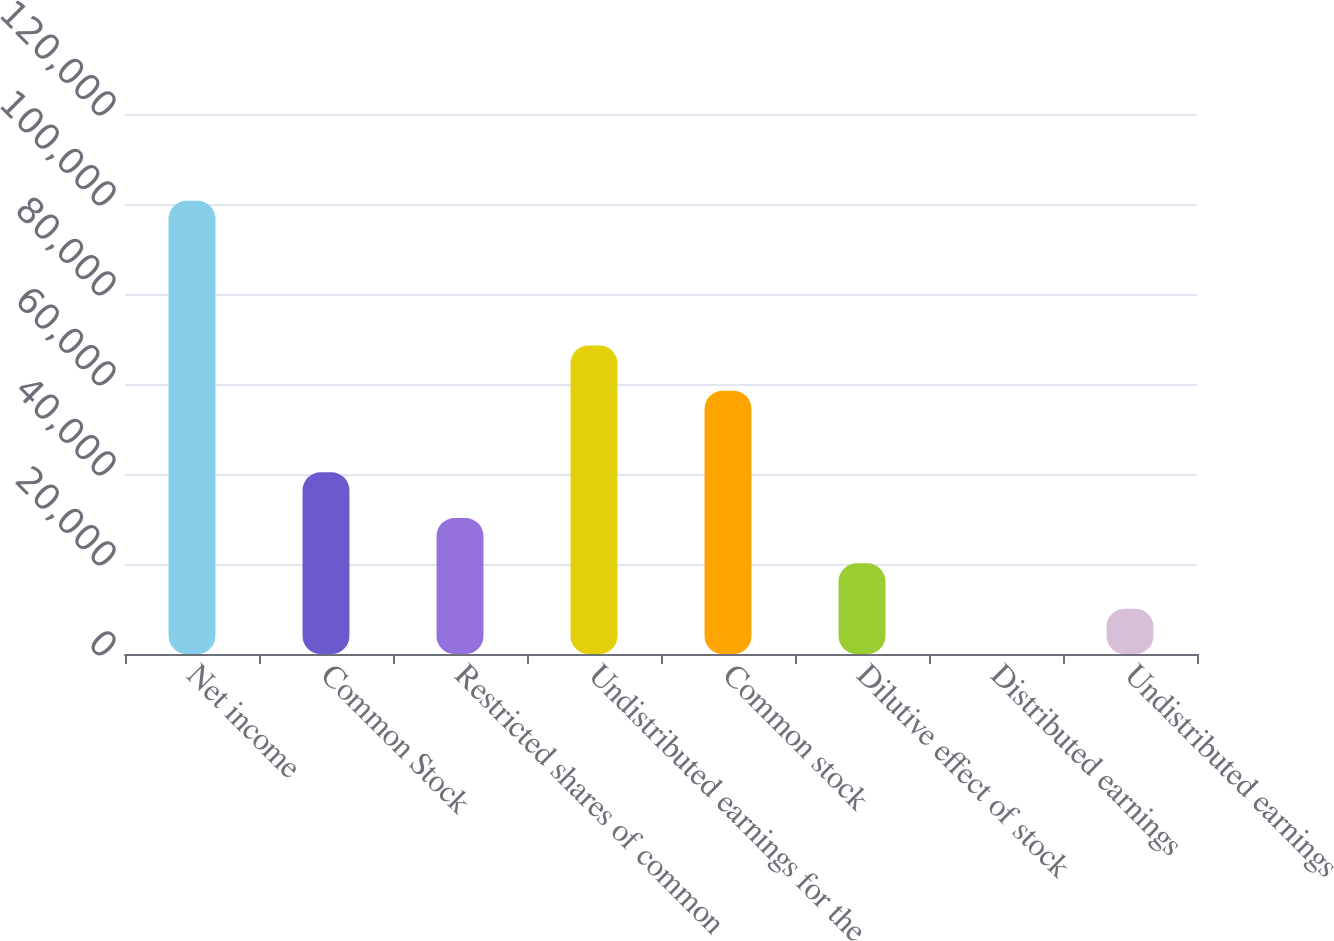Convert chart to OTSL. <chart><loc_0><loc_0><loc_500><loc_500><bar_chart><fcel>Net income<fcel>Common Stock<fcel>Restricted shares of common<fcel>Undistributed earnings for the<fcel>Common stock<fcel>Dilutive effect of stock<fcel>Distributed earnings<fcel>Undistributed earnings<nl><fcel>100711<fcel>40383<fcel>30213.5<fcel>68568.1<fcel>58497<fcel>20142.4<fcel>0.28<fcel>10071.4<nl></chart> 